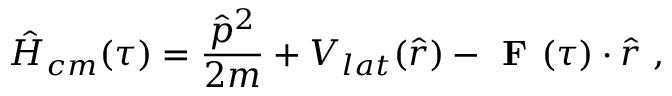<formula> <loc_0><loc_0><loc_500><loc_500>\hat { H } _ { c m } ( \tau ) = \frac { \hat { p } ^ { 2 } } { 2 m } + V _ { l a t } ( \hat { r } ) - F ( \tau ) \cdot \hat { r } ,</formula> 